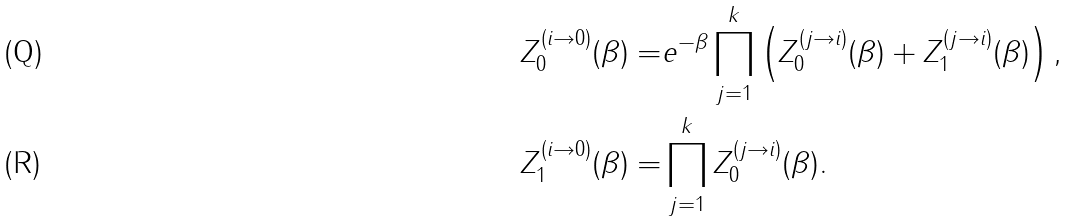<formula> <loc_0><loc_0><loc_500><loc_500>Z _ { 0 } ^ { ( i \to 0 ) } ( \beta ) = & e ^ { - \beta } \prod _ { j = 1 } ^ { k } \left ( Z _ { 0 } ^ { ( j \to i ) } ( \beta ) + Z _ { 1 } ^ { ( j \to i ) } ( \beta ) \right ) , \\ Z _ { 1 } ^ { ( i \to 0 ) } ( \beta ) = & \prod _ { j = 1 } ^ { k } Z _ { 0 } ^ { ( j \to i ) } ( \beta ) .</formula> 